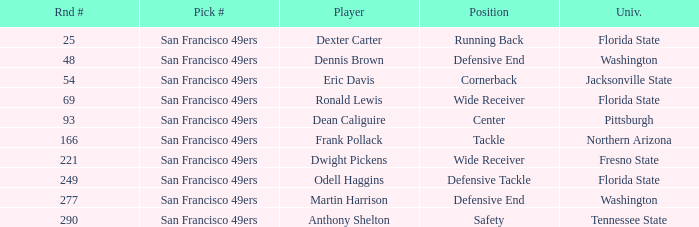What is the College with a Round # that is 290? Tennessee State. 